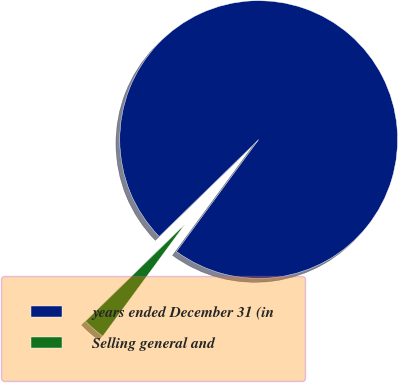Convert chart. <chart><loc_0><loc_0><loc_500><loc_500><pie_chart><fcel>years ended December 31 (in<fcel>Selling general and<nl><fcel>97.38%<fcel>2.62%<nl></chart> 